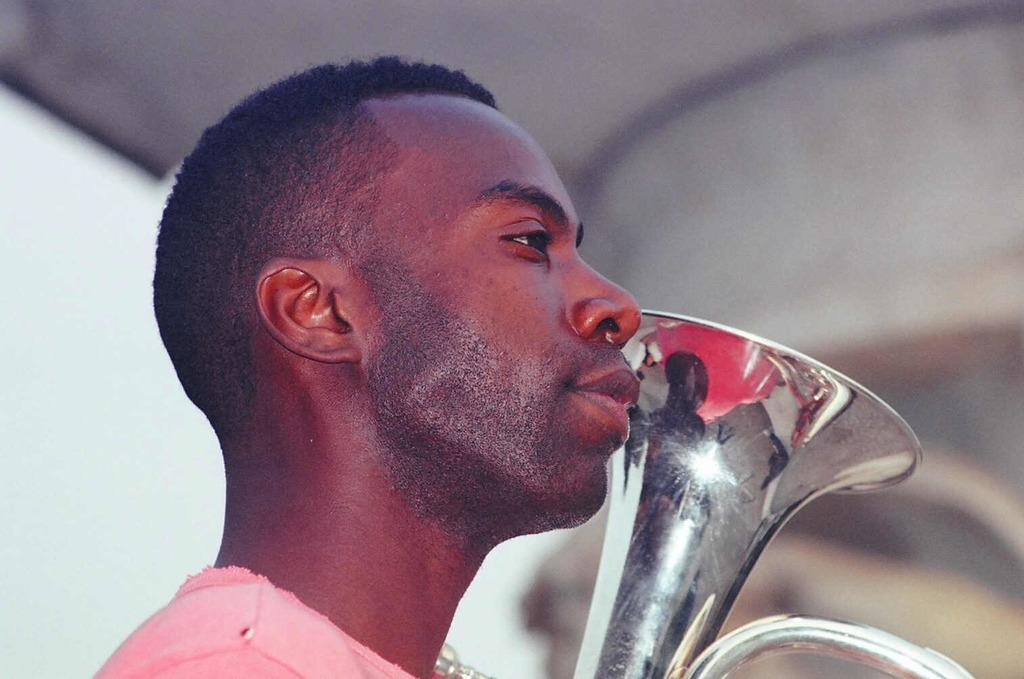What is the person in the image doing? The person is standing in the image. In which direction is the person facing? The person is facing towards the right. What instrument is the person holding? The person is holding a saxophone or a trumpet. Which part of the instrument is visible? The top portion of the instrument is visible. How would you describe the background of the image? The background of the image is blurred. How many nails can be seen in the person's arm in the image? There are no nails visible on the person's arm in the image. What is the person's uncle doing in the background of the image? There is no uncle present in the image, and the background is blurred, so it is not possible to determine any activities. 